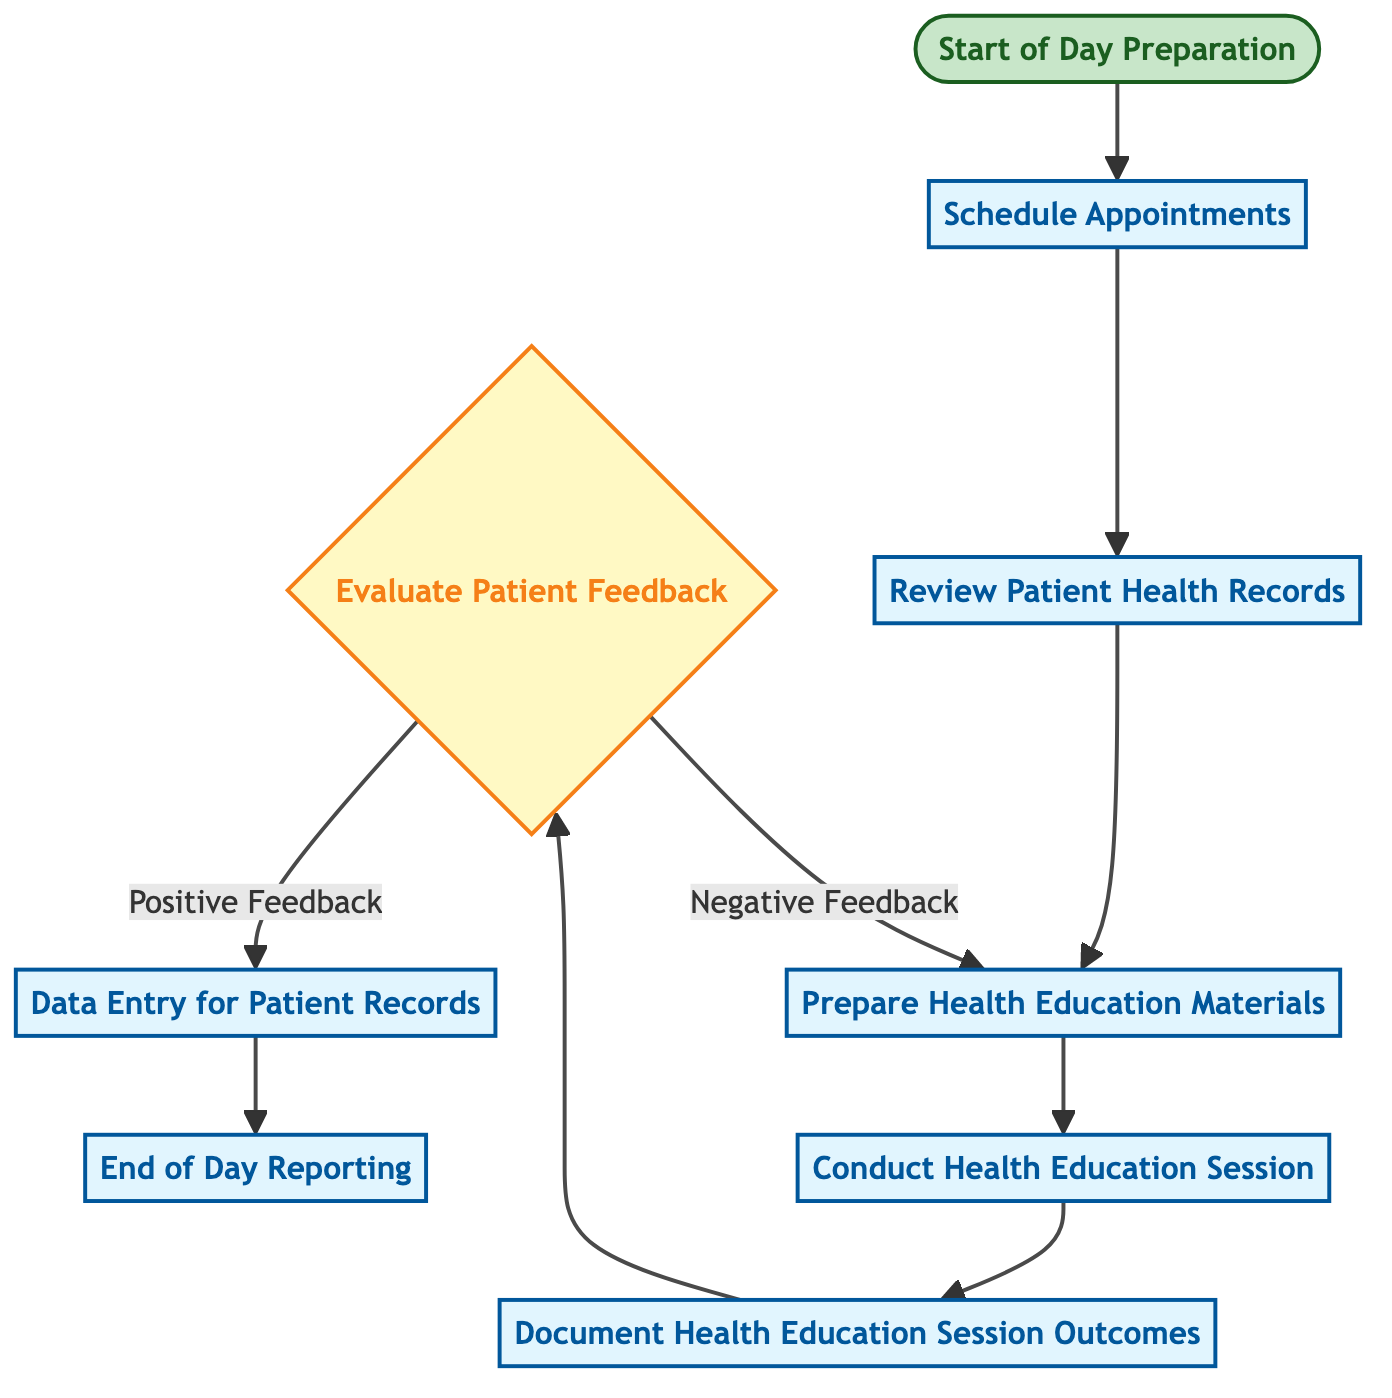What is the first step in the daily workflow? The first step is indicated by the start node labeled "Start of Day Preparation," which initiates the process flow for the day.
Answer: Start of Day Preparation Which process comes after "Document Health Education Session Outcomes"? The flow indicates that after "Document Health Education Session Outcomes," the next step is "Conduct Health Education Session," as specified by the connection links in the diagram.
Answer: Conduct Health Education Session How many decision nodes are present in the diagram? The diagram contains one decision node "Evaluate Patient Feedback," as it is the only node designated with decision characteristics in the flow.
Answer: 1 What is the outcome when "Evaluate Patient Feedback" gives a "Negative Feedback"? Following the decision for "Negative Feedback," the flow directs to "Prepare Health Education Materials," requiring a preparation step before re-evaluating the next session's materials.
Answer: Prepare Health Education Materials What process occurs right before "End of Day Reporting"? The last process before reaching "End of Day Reporting" is "Data Entry for Patient Records,” making it the direct precursor in the flow.
Answer: Data Entry for Patient Records Which node receives data in response to positive feedback? After evaluating for positive feedback, the diagram directs to "Data Entry for Patient Records," indicating that this is where the positive feedback leads to relevant record-keeping.
Answer: Data Entry for Patient Records What is the total number of processes in the diagram? By counting, there are a total of seven processes listed in the diagram: Start of Day Preparation, Schedule Appointments, Review Patient Health Records, Prepare Health Education Materials, Conduct Health Education Session, Document Health Education Session Outcomes, and End of Day Reporting.
Answer: 7 What action is taken immediately after "Prepare Health Education Materials"? The flow shows that immediately after "Prepare Health Education Materials," the next action is "Conduct Health Education Session,” indicating the transition from preparation to execution.
Answer: Conduct Health Education Session 